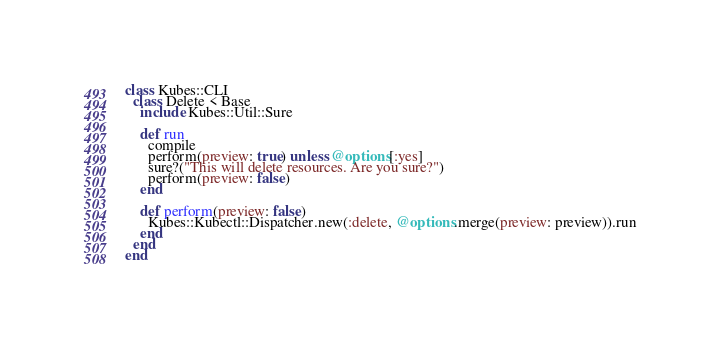Convert code to text. <code><loc_0><loc_0><loc_500><loc_500><_Ruby_>class Kubes::CLI
  class Delete < Base
    include Kubes::Util::Sure

    def run
      compile
      perform(preview: true) unless @options[:yes]
      sure?("This will delete resources. Are you sure?")
      perform(preview: false)
    end

    def perform(preview: false)
      Kubes::Kubectl::Dispatcher.new(:delete, @options.merge(preview: preview)).run
    end
  end
end
</code> 